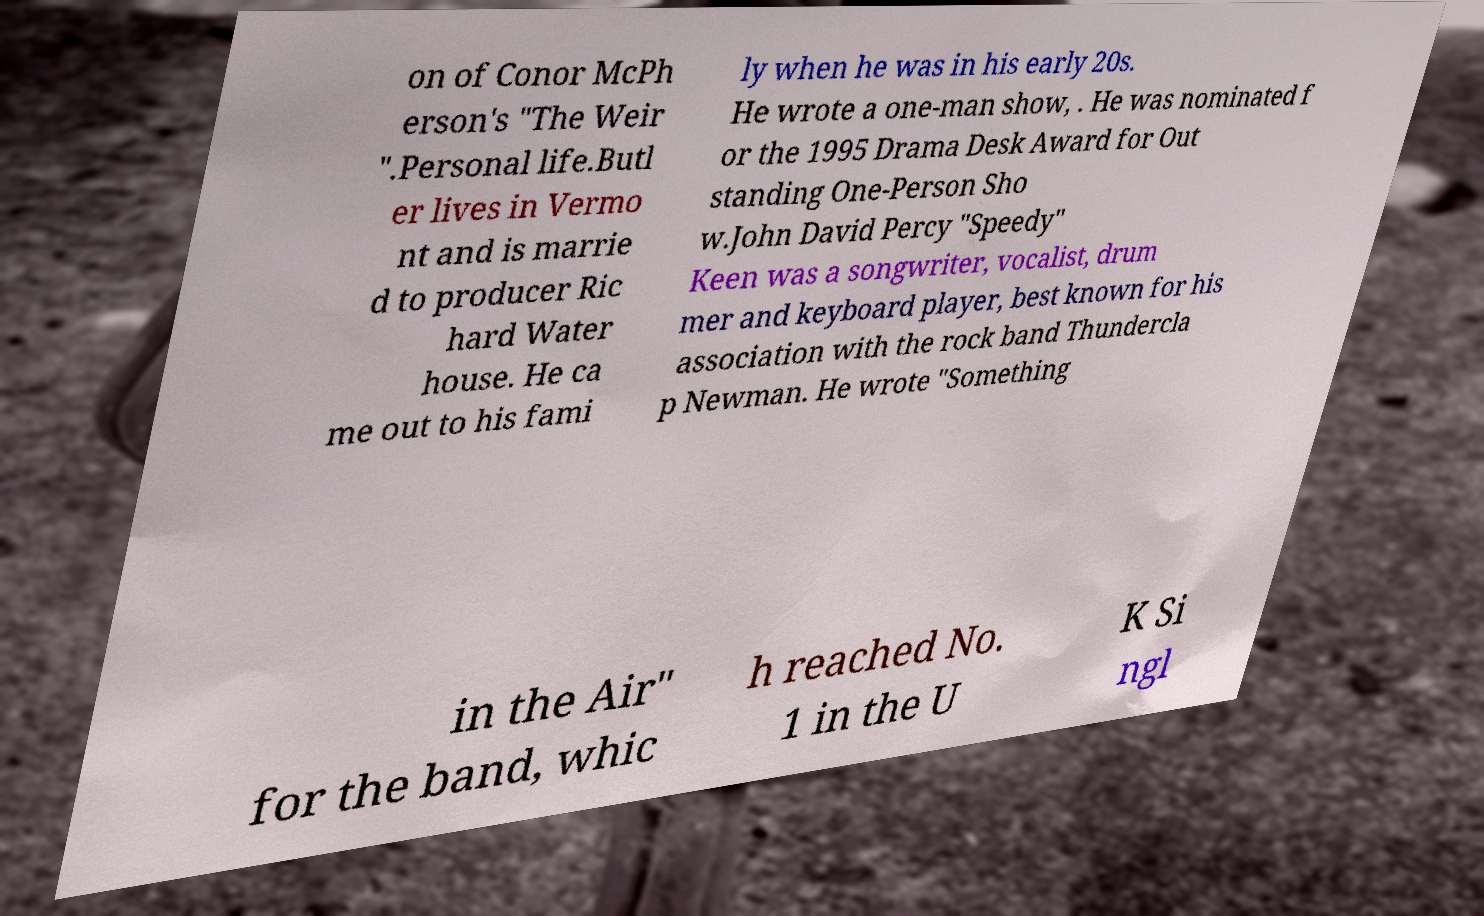Please read and relay the text visible in this image. What does it say? on of Conor McPh erson's "The Weir ".Personal life.Butl er lives in Vermo nt and is marrie d to producer Ric hard Water house. He ca me out to his fami ly when he was in his early 20s. He wrote a one-man show, . He was nominated f or the 1995 Drama Desk Award for Out standing One-Person Sho w.John David Percy "Speedy" Keen was a songwriter, vocalist, drum mer and keyboard player, best known for his association with the rock band Thundercla p Newman. He wrote "Something in the Air" for the band, whic h reached No. 1 in the U K Si ngl 